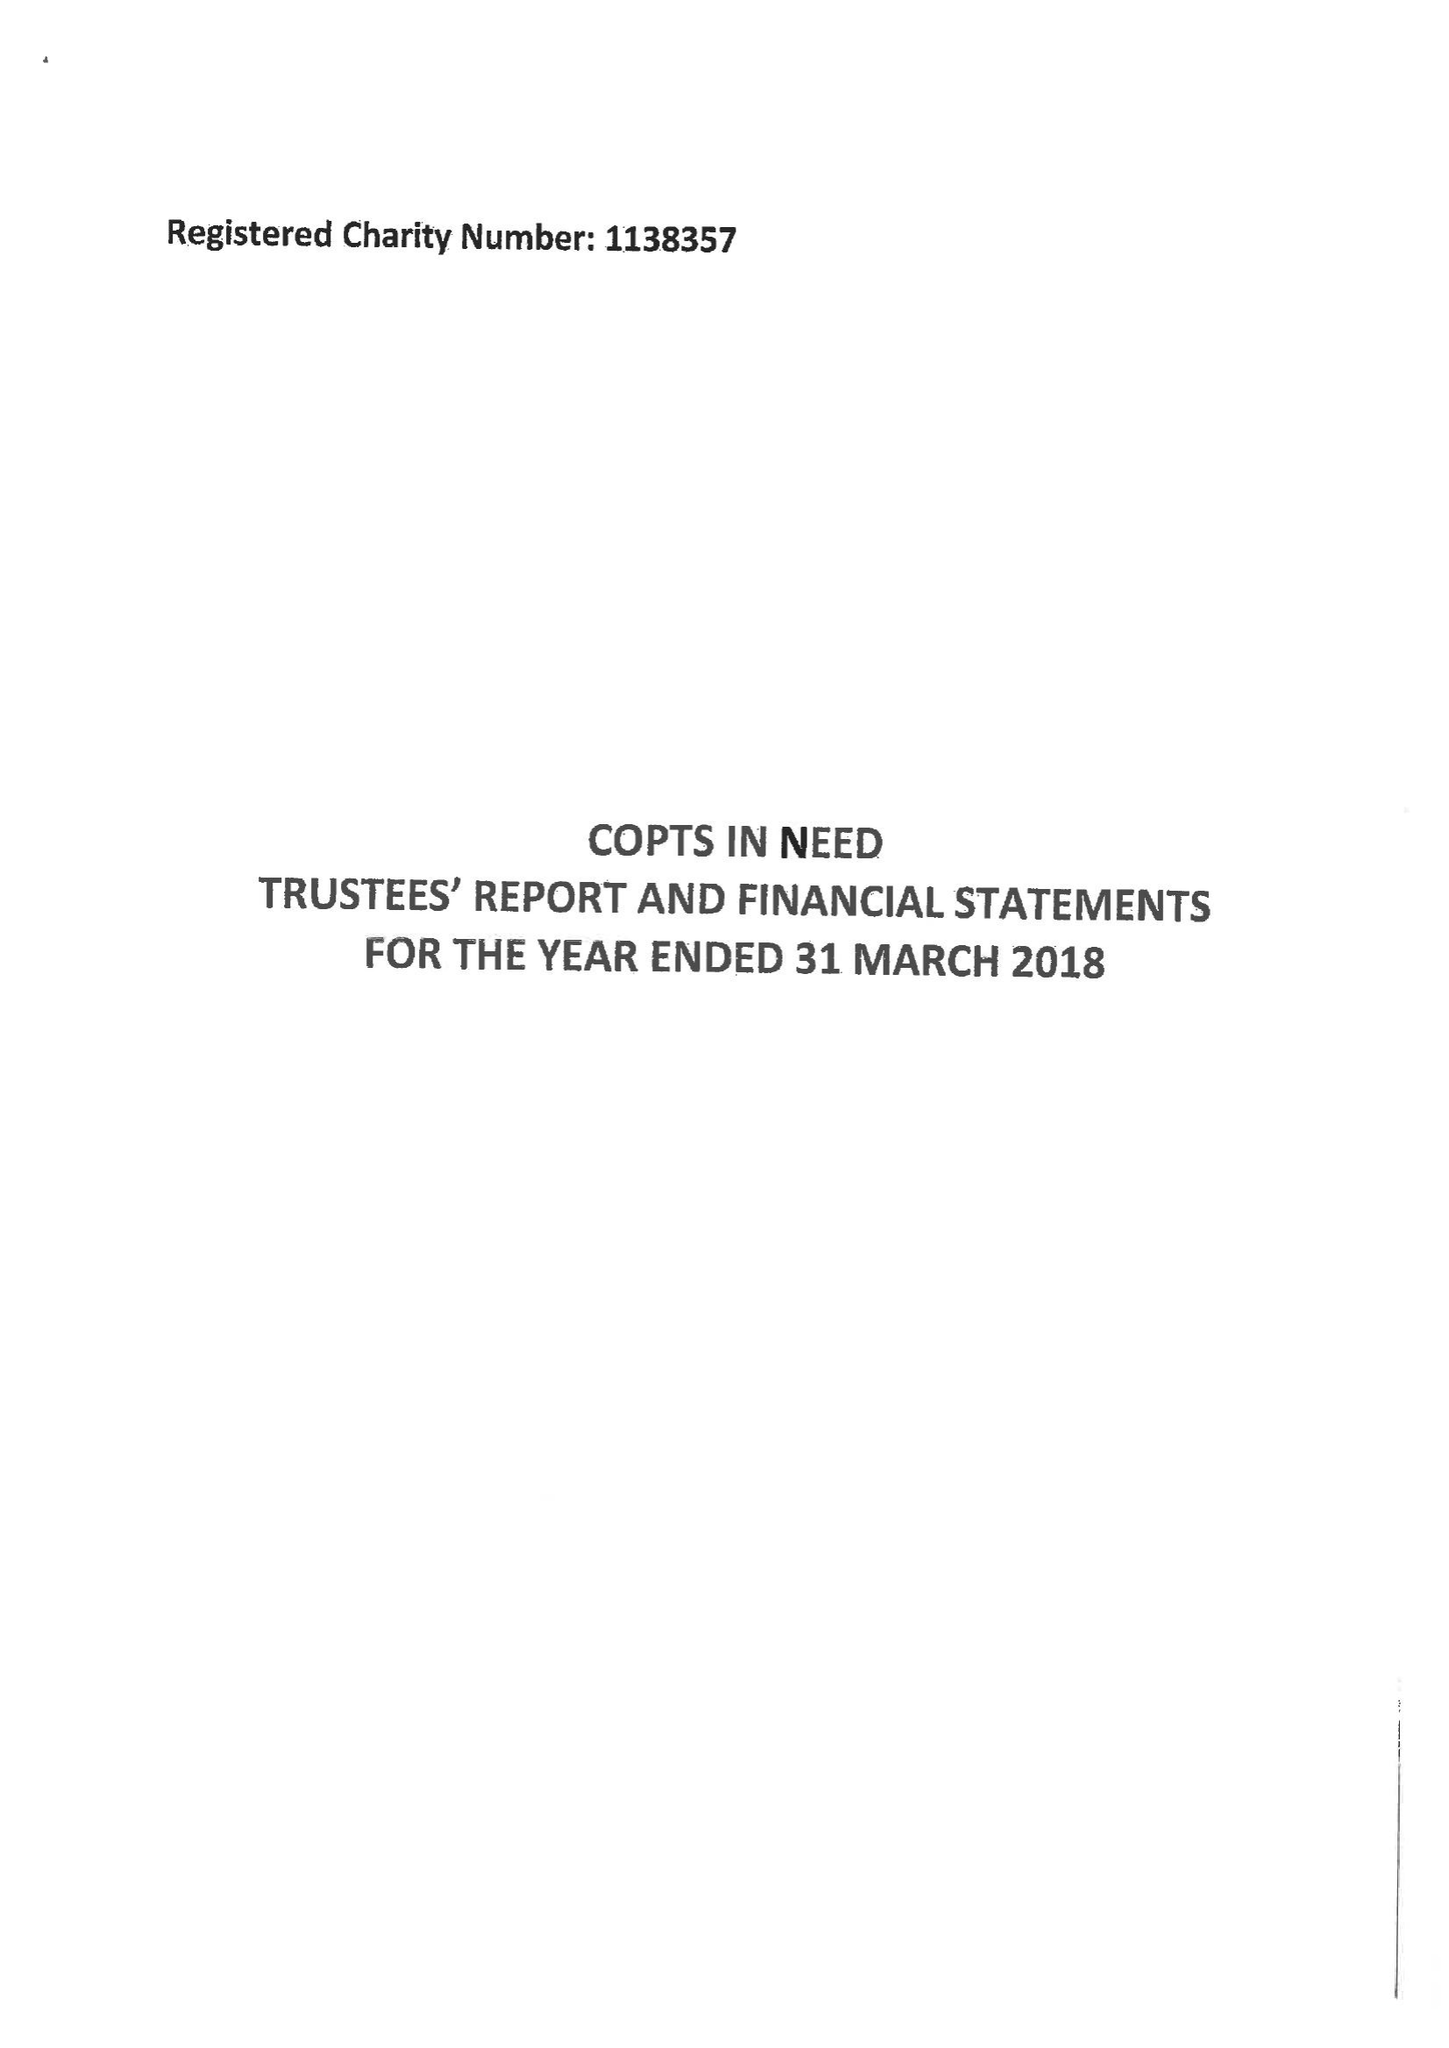What is the value for the address__street_line?
Answer the question using a single word or phrase. 5 GLENFALL CLOSE 